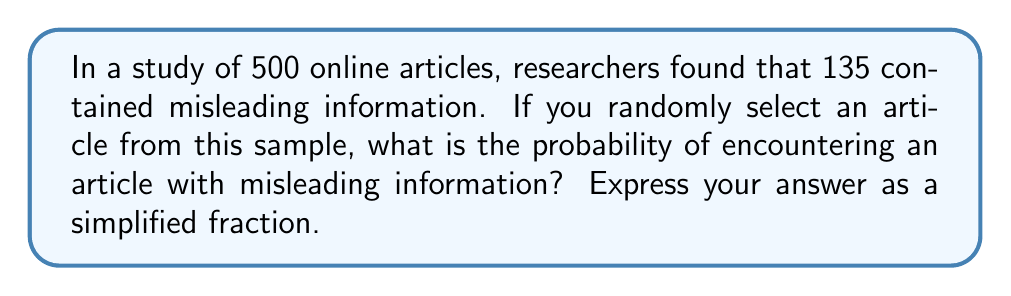Solve this math problem. To solve this problem, we need to understand the concept of probability. Probability is calculated by dividing the number of favorable outcomes by the total number of possible outcomes.

In this case:
- Total number of articles: 500
- Number of articles with misleading information: 135

The probability is calculated as follows:

$$P(\text{misleading}) = \frac{\text{Number of articles with misleading information}}{\text{Total number of articles}}$$

$$P(\text{misleading}) = \frac{135}{500}$$

To simplify this fraction, we need to find the greatest common divisor (GCD) of 135 and 500:

$GCD(135, 500) = 5$

Now, divide both the numerator and denominator by 5:

$$\frac{135 \div 5}{500 \div 5} = \frac{27}{100}$$

Therefore, the probability of encountering an article with misleading information is $\frac{27}{100}$.
Answer: $\frac{27}{100}$ 